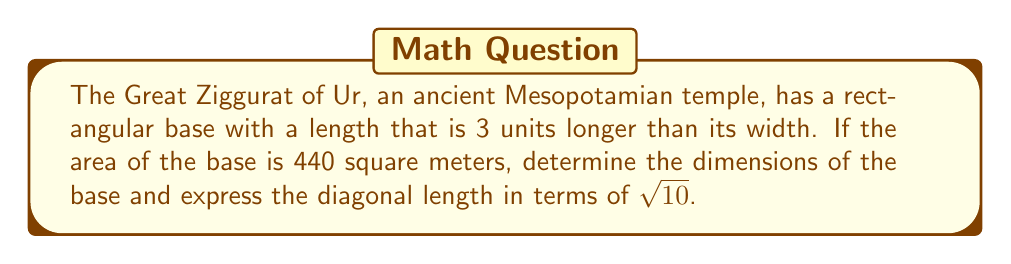Solve this math problem. Let's approach this step-by-step:

1) Let the width of the base be $x$ meters. Then the length is $(x+3)$ meters.

2) The area of a rectangle is given by length times width. So we can write:
   $x(x+3) = 440$

3) Expand the equation:
   $x^2 + 3x = 440$

4) Rearrange to standard form:
   $x^2 + 3x - 440 = 0$

5) This is a quadratic equation. We can solve it using the quadratic formula:
   $x = \frac{-b \pm \sqrt{b^2 - 4ac}}{2a}$

   Where $a=1$, $b=3$, and $c=-440$

6) Substituting these values:
   $x = \frac{-3 \pm \sqrt{3^2 - 4(1)(-440)}}{2(1)}$
   $= \frac{-3 \pm \sqrt{9 + 1760}}{2}$
   $= \frac{-3 \pm \sqrt{1769}}{2}$

7) Simplify:
   $x = \frac{-3 \pm 42.06}{2}$

8) This gives us two solutions: $x \approx 19.53$ or $x \approx -22.53$

9) Since length cannot be negative, we take the positive solution.
   Width $\approx 19.53$ meters, Length $\approx 22.53$ meters

10) For the diagonal, we can use the Pythagorean theorem:
    $d^2 = 19.53^2 + 22.53^2$
    $d^2 = 381.42 + 507.60 = 889.02$

11) Simplify:
    $d = \sqrt{889.02} = \sqrt{88.902 \times 10} \approx 9.43\sqrt{10}$

Therefore, the diagonal can be expressed as $3\sqrt{990}$ meters, which simplifies to $9.43\sqrt{10}$ meters.
Answer: Width: $19.53$ m, Length: $22.53$ m, Diagonal: $9.43\sqrt{10}$ m 